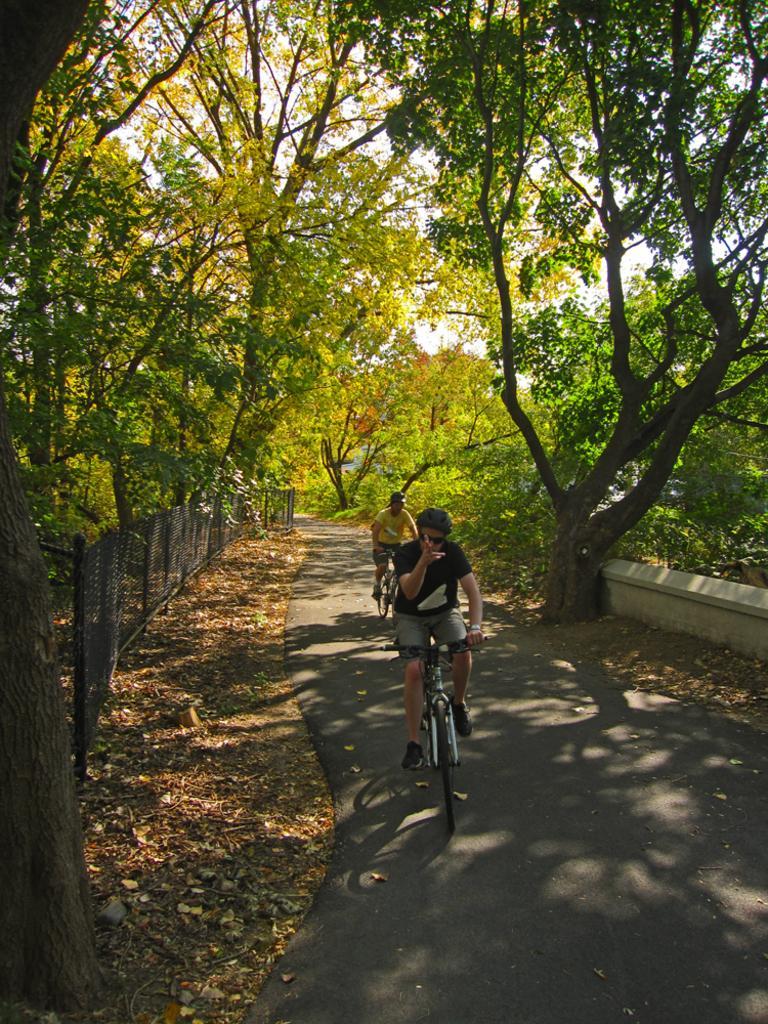How would you summarize this image in a sentence or two? This picture is clicked outside. In the center we can see the two people riding their bicycles, and on both the sides we can see the trees. On the left we can see the mesh and the metal rods and we can see the dry leaves lying on the ground. In the background we can see the sky, trees and plants. 